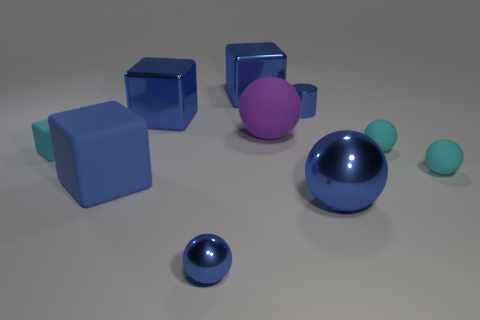There is a cyan rubber ball that is behind the tiny cyan rubber block; what number of small rubber spheres are in front of it?
Make the answer very short. 1. The big block that is made of the same material as the purple thing is what color?
Your answer should be compact. Blue. Is there a cyan matte object of the same size as the purple object?
Ensure brevity in your answer.  No. There is a blue matte thing that is the same size as the purple rubber object; what shape is it?
Give a very brief answer. Cube. Are there any small metal objects that have the same shape as the big blue matte thing?
Your response must be concise. No. Does the small cyan cube have the same material as the tiny blue thing in front of the tiny rubber cube?
Ensure brevity in your answer.  No. Is there a big shiny object that has the same color as the small metal sphere?
Give a very brief answer. Yes. How many other things are made of the same material as the small cyan block?
Your response must be concise. 4. Do the small metallic cylinder and the small metal thing in front of the large shiny ball have the same color?
Provide a succinct answer. Yes. Is the number of large purple rubber spheres that are left of the small cyan matte cube greater than the number of blocks?
Offer a terse response. No. 